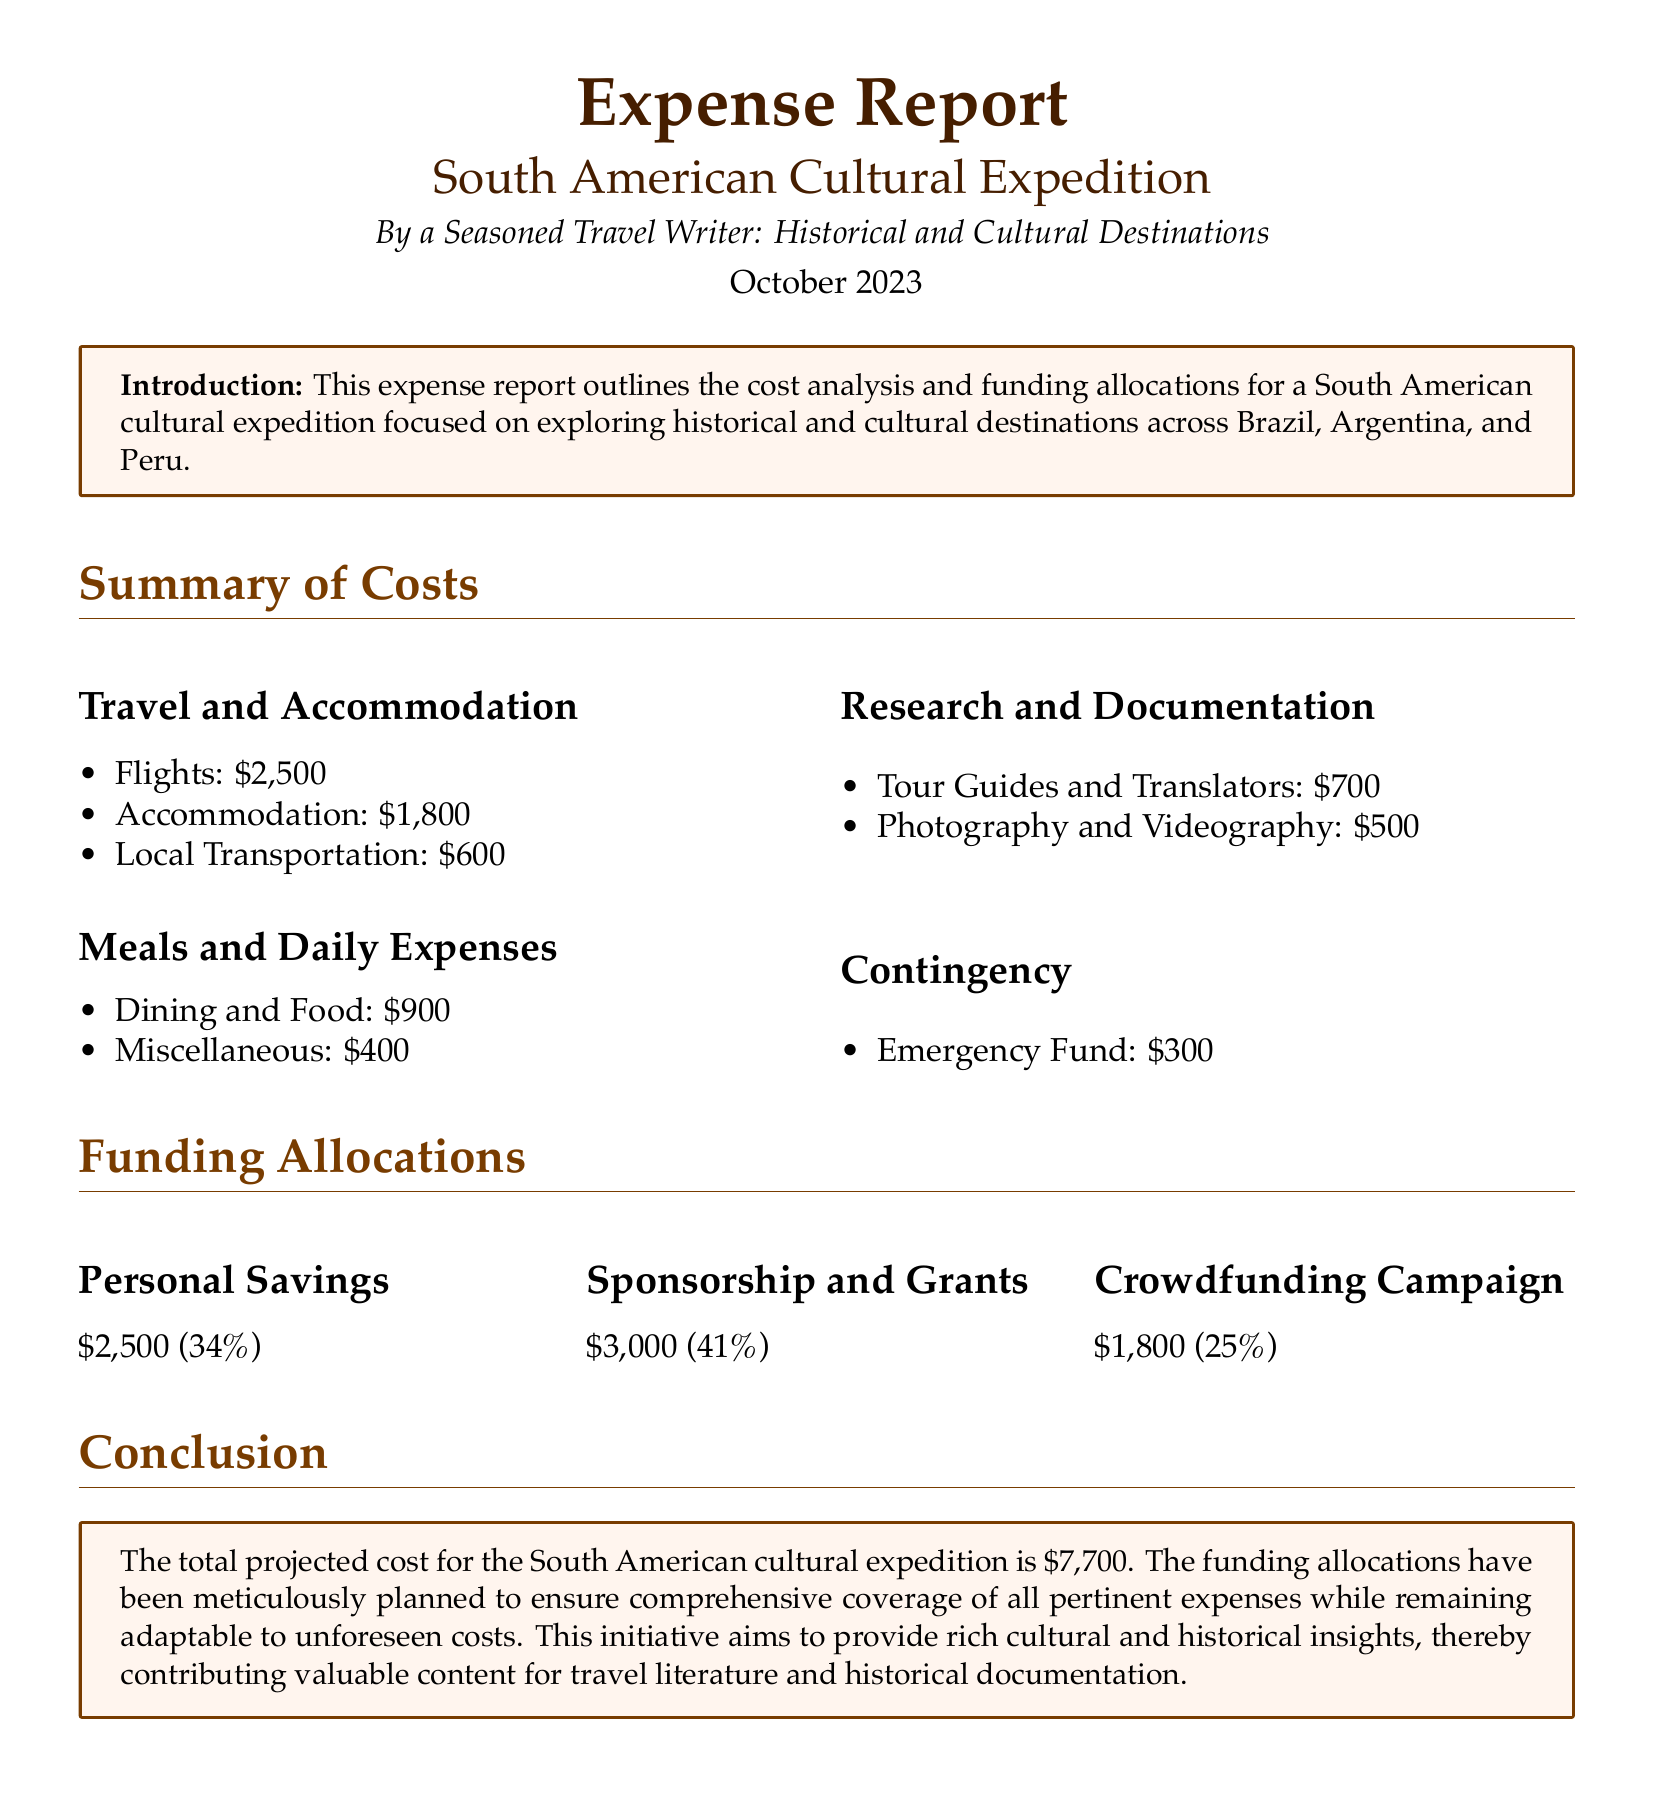What is the total projected cost? The total projected cost is mentioned in the conclusion section of the document as $7,700.
Answer: $7,700 How much was allocated for local transportation? The amount allocated for local transportation is found in the 'Travel and Accommodation' section, which states $600.
Answer: $600 What percentage of funding came from sponsorship and grants? The funding source of sponsorship and grants is detailed in the 'Funding Allocations' section and is stated as 41%.
Answer: 41% What is included under 'Research and Documentation'? The items listed under 'Research and Documentation' include Tour Guides and Translators and Photography and Videography, totaling $1,200.
Answer: Tour Guides and Translators, Photography and Videography How much did the expedition allocate for the emergency fund? The emergency fund is specified in the 'Contingency' section as $300.
Answer: $300 What is the total amount for Meals and Daily Expenses? 'Meals and Daily Expenses' is broken down into Dining and Food and Miscellaneous, which total $1,300.
Answer: $1,300 Who authored the document? The author's identity is stated in the introduction as a seasoned travel writer focusing on historical and cultural destinations.
Answer: A Seasoned Travel Writer What is the main purpose of the expedition? The main purpose is outlined in the introduction and is aimed at providing rich cultural and historical insights.
Answer: Exploring historical and cultural destinations 